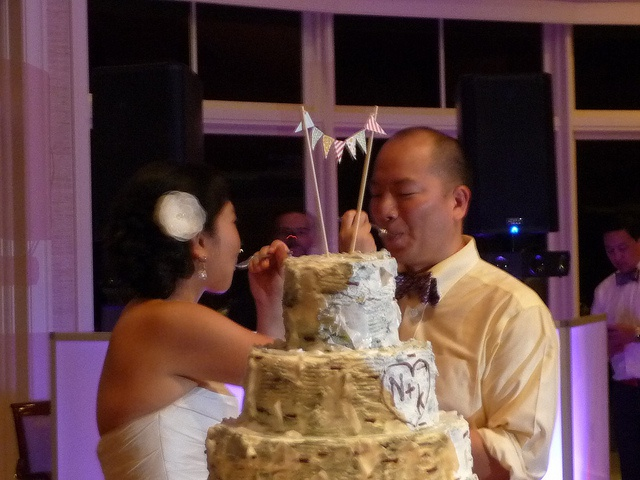Describe the objects in this image and their specific colors. I can see cake in maroon, tan, olive, and lightgray tones, people in maroon, brown, and tan tones, people in maroon, black, and brown tones, people in maroon, black, and purple tones, and chair in maroon, black, and purple tones in this image. 